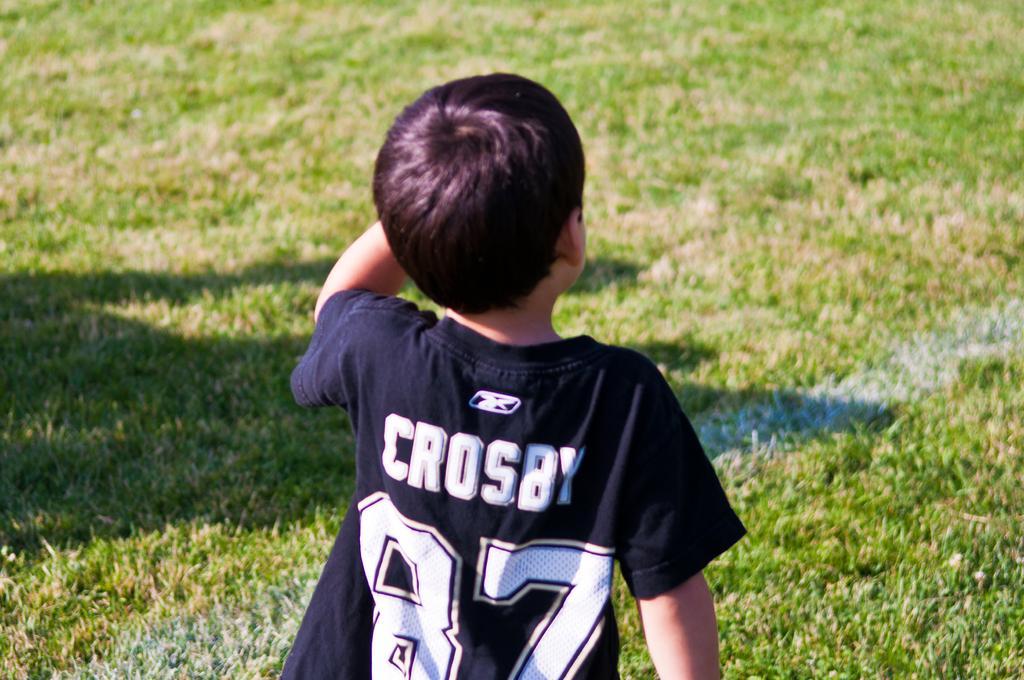What number does crosby have?
Keep it short and to the point. 87. What is the jersey last name?
Your answer should be very brief. Crosby. 